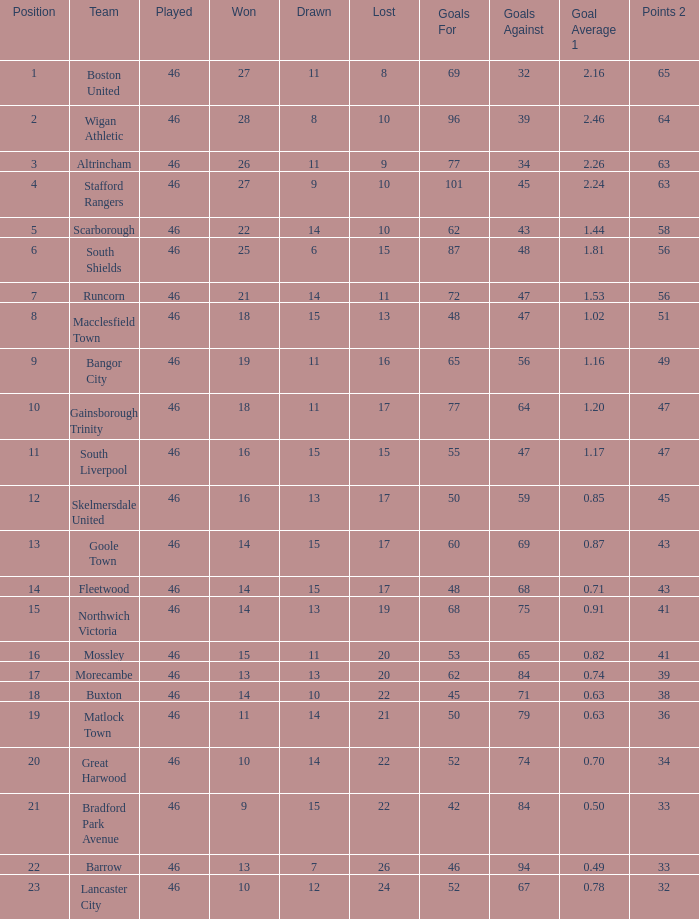For the team with 60 goals, how many games did they win? 14.0. 